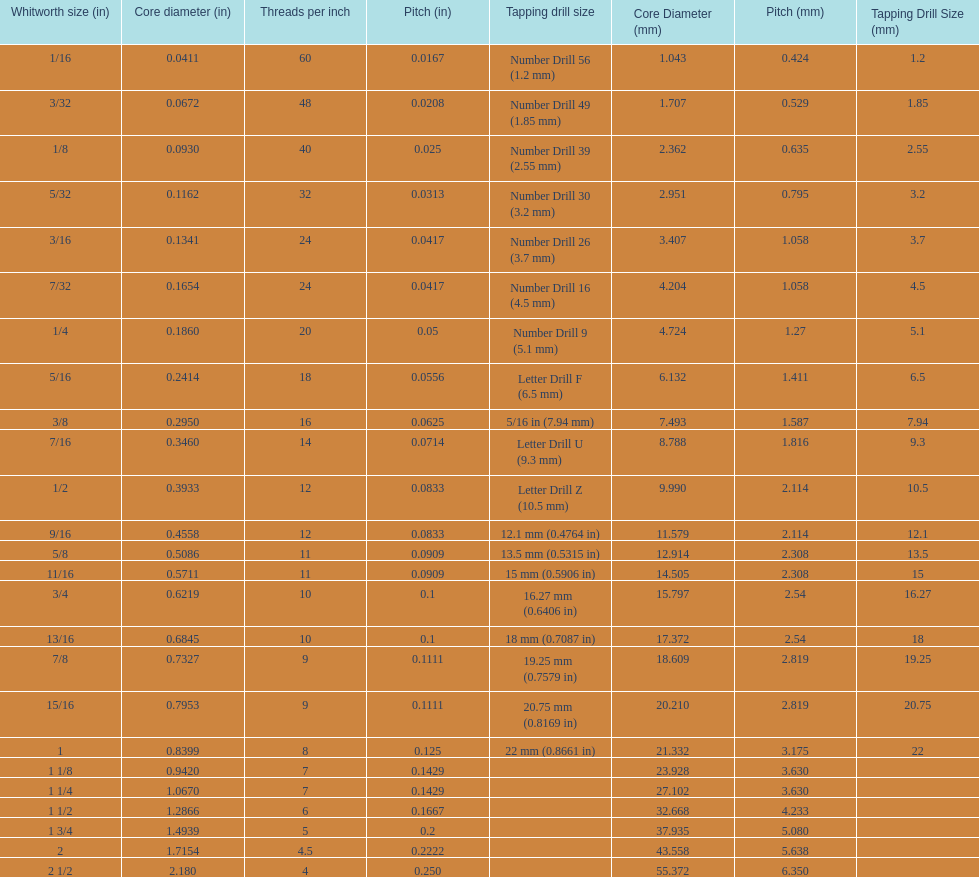What is the top amount of threads per inch? 60. 